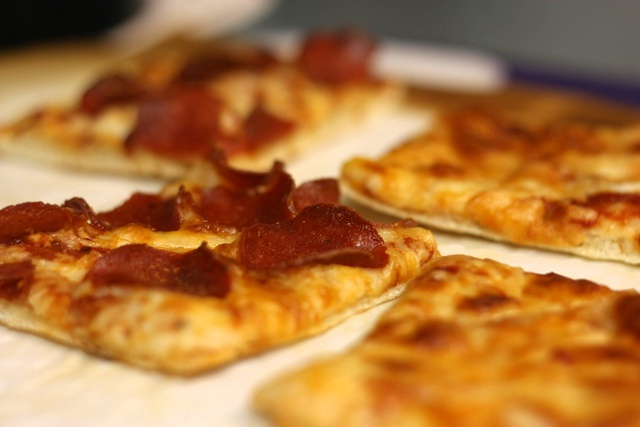Describe the objects in this image and their specific colors. I can see pizza in black, maroon, orange, and red tones, pizza in black, orange, and red tones, pizza in black, brown, maroon, and tan tones, and pizza in black, brown, orange, and maroon tones in this image. 